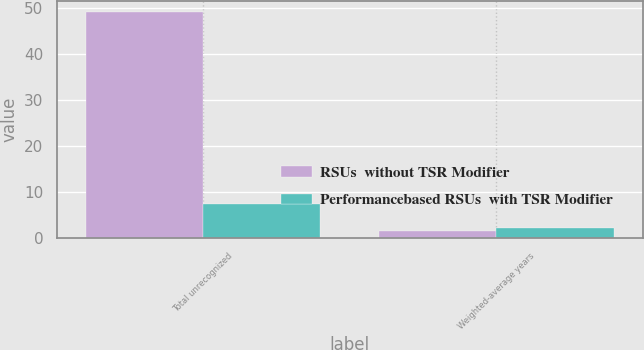<chart> <loc_0><loc_0><loc_500><loc_500><stacked_bar_chart><ecel><fcel>Total unrecognized<fcel>Weighted-average years<nl><fcel>RSUs  without TSR Modifier<fcel>49.1<fcel>1.6<nl><fcel>Performancebased RSUs  with TSR Modifier<fcel>7.4<fcel>2.2<nl></chart> 